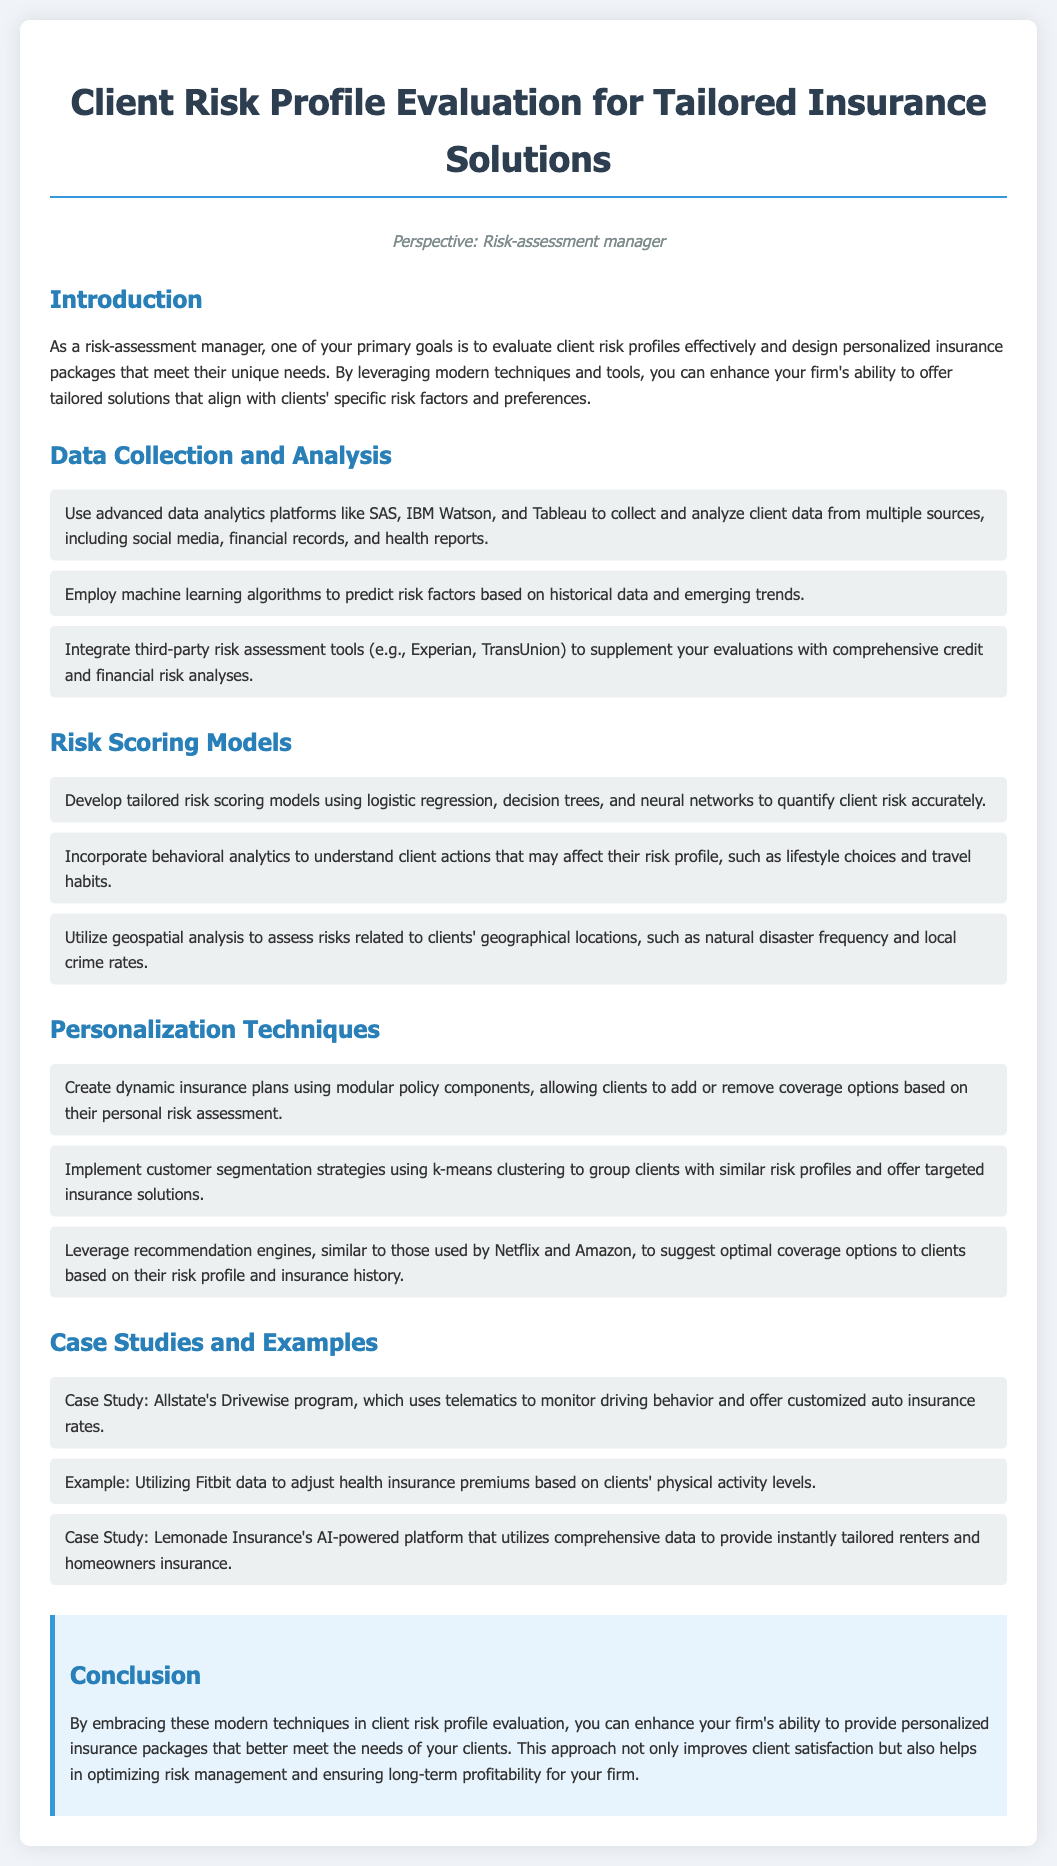What is the primary goal of a risk-assessment manager? The primary goal is to evaluate client risk profiles effectively and design personalized insurance packages.
Answer: Evaluate client risk profiles What technique is suggested for data analysis? The document mentions using advanced data analytics platforms like SAS, IBM Watson, and Tableau.
Answer: Advanced data analytics platforms What type of algorithms are recommended for predicting risk factors? The document recommends using machine learning algorithms to predict risk factors.
Answer: Machine learning algorithms Which analysis is used to assess risks related to geographical locations? Geospatial analysis is mentioned for assessing risks related to clients' geographical locations.
Answer: Geospatial analysis What is a personalization technique suggested in the document? The document suggests creating dynamic insurance plans using modular policy components.
Answer: Dynamic insurance plans What case study is mentioned for customized auto insurance rates? Allstate's Drivewise program is mentioned as a case study.
Answer: Allstate's Drivewise program What customer segmentation strategy is recommended? The document suggests using k-means clustering for customer segmentation.
Answer: K-means clustering What example is given for adjusting health insurance premiums? Utilizing Fitbit data to adjust health insurance premiums based on physical activity levels is given as an example.
Answer: Utilizing Fitbit data 